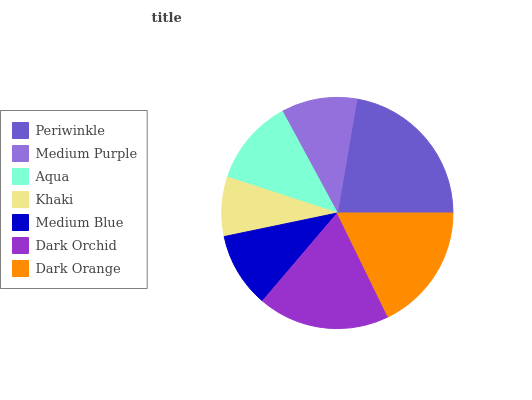Is Khaki the minimum?
Answer yes or no. Yes. Is Periwinkle the maximum?
Answer yes or no. Yes. Is Medium Purple the minimum?
Answer yes or no. No. Is Medium Purple the maximum?
Answer yes or no. No. Is Periwinkle greater than Medium Purple?
Answer yes or no. Yes. Is Medium Purple less than Periwinkle?
Answer yes or no. Yes. Is Medium Purple greater than Periwinkle?
Answer yes or no. No. Is Periwinkle less than Medium Purple?
Answer yes or no. No. Is Aqua the high median?
Answer yes or no. Yes. Is Aqua the low median?
Answer yes or no. Yes. Is Khaki the high median?
Answer yes or no. No. Is Medium Purple the low median?
Answer yes or no. No. 